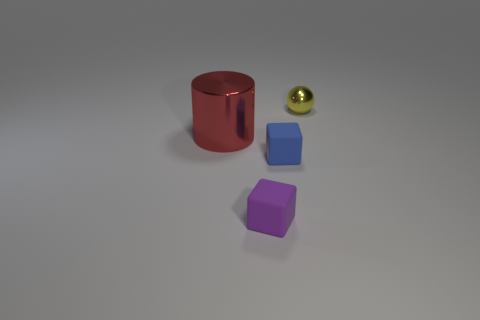How would these objects be used in a physics experiment? These objects could serve various roles in a physics experiment. For instance, the differing materials and weights could be used to demonstrate principles of gravity, friction, or even optics if light reflections are involved. The distinct geometries could also prove useful in experiments exploring volume, density, or surface area and its effects on motion and stability. 